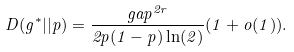Convert formula to latex. <formula><loc_0><loc_0><loc_500><loc_500>D ( g ^ { * } | | p ) = \frac { g a p ^ { 2 r } } { 2 p ( 1 - p ) \ln ( 2 ) } ( 1 + o ( 1 ) ) .</formula> 